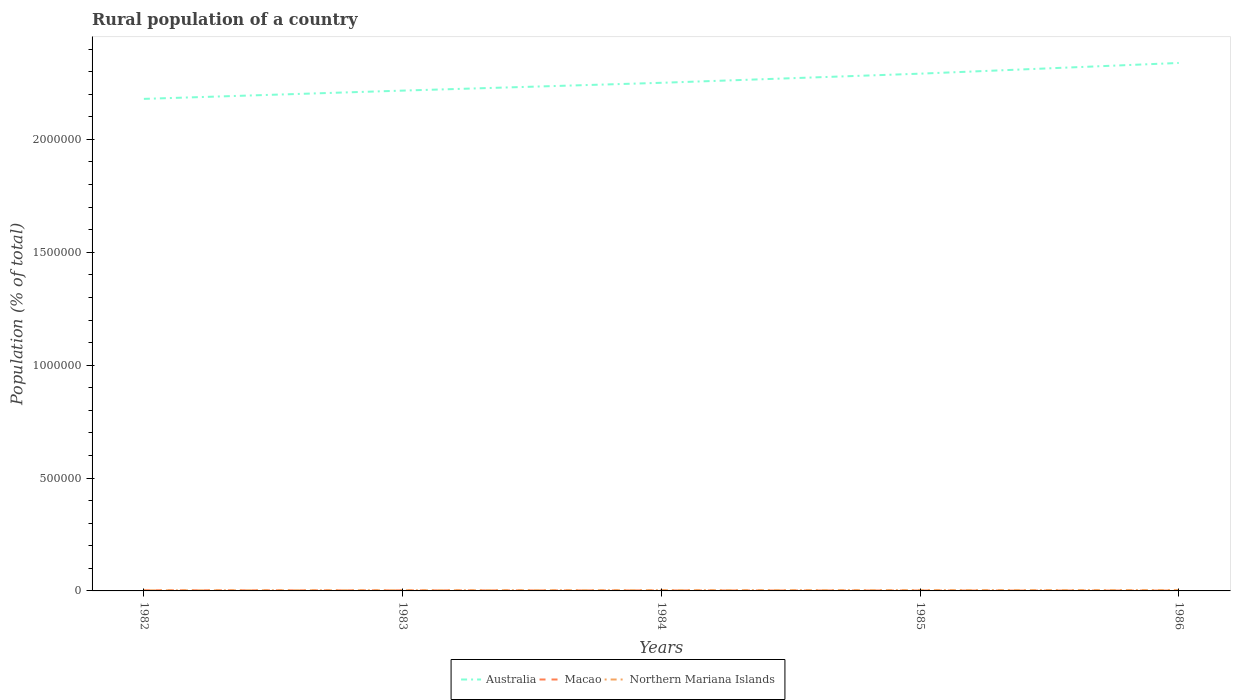Does the line corresponding to Northern Mariana Islands intersect with the line corresponding to Australia?
Your response must be concise. No. Across all years, what is the maximum rural population in Macao?
Keep it short and to the point. 1589. What is the total rural population in Macao in the graph?
Keep it short and to the point. 1310. What is the difference between the highest and the second highest rural population in Northern Mariana Islands?
Offer a terse response. 1070. What is the difference between the highest and the lowest rural population in Macao?
Your answer should be compact. 2. Is the rural population in Macao strictly greater than the rural population in Australia over the years?
Your response must be concise. Yes. Are the values on the major ticks of Y-axis written in scientific E-notation?
Provide a short and direct response. No. Does the graph contain any zero values?
Provide a succinct answer. No. Does the graph contain grids?
Ensure brevity in your answer.  No. Where does the legend appear in the graph?
Offer a terse response. Bottom center. How many legend labels are there?
Make the answer very short. 3. What is the title of the graph?
Your answer should be very brief. Rural population of a country. Does "Cabo Verde" appear as one of the legend labels in the graph?
Provide a short and direct response. No. What is the label or title of the Y-axis?
Offer a terse response. Population (% of total). What is the Population (% of total) of Australia in 1982?
Ensure brevity in your answer.  2.18e+06. What is the Population (% of total) in Macao in 1982?
Keep it short and to the point. 2899. What is the Population (% of total) in Northern Mariana Islands in 1982?
Keep it short and to the point. 2686. What is the Population (% of total) in Australia in 1983?
Your answer should be compact. 2.22e+06. What is the Population (% of total) of Macao in 1983?
Keep it short and to the point. 2489. What is the Population (% of total) in Northern Mariana Islands in 1983?
Give a very brief answer. 2975. What is the Population (% of total) in Australia in 1984?
Your answer should be compact. 2.25e+06. What is the Population (% of total) in Macao in 1984?
Offer a terse response. 2145. What is the Population (% of total) in Northern Mariana Islands in 1984?
Your answer should be very brief. 3263. What is the Population (% of total) in Australia in 1985?
Make the answer very short. 2.29e+06. What is the Population (% of total) in Macao in 1985?
Your response must be concise. 1845. What is the Population (% of total) in Northern Mariana Islands in 1985?
Ensure brevity in your answer.  3525. What is the Population (% of total) in Australia in 1986?
Keep it short and to the point. 2.34e+06. What is the Population (% of total) in Macao in 1986?
Provide a succinct answer. 1589. What is the Population (% of total) of Northern Mariana Islands in 1986?
Give a very brief answer. 3756. Across all years, what is the maximum Population (% of total) in Australia?
Give a very brief answer. 2.34e+06. Across all years, what is the maximum Population (% of total) in Macao?
Offer a very short reply. 2899. Across all years, what is the maximum Population (% of total) of Northern Mariana Islands?
Provide a short and direct response. 3756. Across all years, what is the minimum Population (% of total) of Australia?
Offer a terse response. 2.18e+06. Across all years, what is the minimum Population (% of total) in Macao?
Your answer should be very brief. 1589. Across all years, what is the minimum Population (% of total) in Northern Mariana Islands?
Your answer should be very brief. 2686. What is the total Population (% of total) of Australia in the graph?
Offer a very short reply. 1.13e+07. What is the total Population (% of total) of Macao in the graph?
Your answer should be compact. 1.10e+04. What is the total Population (% of total) in Northern Mariana Islands in the graph?
Ensure brevity in your answer.  1.62e+04. What is the difference between the Population (% of total) of Australia in 1982 and that in 1983?
Make the answer very short. -3.66e+04. What is the difference between the Population (% of total) in Macao in 1982 and that in 1983?
Your answer should be compact. 410. What is the difference between the Population (% of total) of Northern Mariana Islands in 1982 and that in 1983?
Your answer should be compact. -289. What is the difference between the Population (% of total) of Australia in 1982 and that in 1984?
Make the answer very short. -7.12e+04. What is the difference between the Population (% of total) of Macao in 1982 and that in 1984?
Give a very brief answer. 754. What is the difference between the Population (% of total) of Northern Mariana Islands in 1982 and that in 1984?
Your response must be concise. -577. What is the difference between the Population (% of total) in Australia in 1982 and that in 1985?
Offer a terse response. -1.12e+05. What is the difference between the Population (% of total) in Macao in 1982 and that in 1985?
Provide a short and direct response. 1054. What is the difference between the Population (% of total) of Northern Mariana Islands in 1982 and that in 1985?
Give a very brief answer. -839. What is the difference between the Population (% of total) in Australia in 1982 and that in 1986?
Give a very brief answer. -1.59e+05. What is the difference between the Population (% of total) of Macao in 1982 and that in 1986?
Your response must be concise. 1310. What is the difference between the Population (% of total) of Northern Mariana Islands in 1982 and that in 1986?
Make the answer very short. -1070. What is the difference between the Population (% of total) of Australia in 1983 and that in 1984?
Give a very brief answer. -3.46e+04. What is the difference between the Population (% of total) of Macao in 1983 and that in 1984?
Your answer should be compact. 344. What is the difference between the Population (% of total) of Northern Mariana Islands in 1983 and that in 1984?
Provide a succinct answer. -288. What is the difference between the Population (% of total) of Australia in 1983 and that in 1985?
Provide a succinct answer. -7.50e+04. What is the difference between the Population (% of total) of Macao in 1983 and that in 1985?
Offer a very short reply. 644. What is the difference between the Population (% of total) of Northern Mariana Islands in 1983 and that in 1985?
Your answer should be compact. -550. What is the difference between the Population (% of total) in Australia in 1983 and that in 1986?
Keep it short and to the point. -1.22e+05. What is the difference between the Population (% of total) of Macao in 1983 and that in 1986?
Make the answer very short. 900. What is the difference between the Population (% of total) of Northern Mariana Islands in 1983 and that in 1986?
Make the answer very short. -781. What is the difference between the Population (% of total) in Australia in 1984 and that in 1985?
Make the answer very short. -4.04e+04. What is the difference between the Population (% of total) of Macao in 1984 and that in 1985?
Your response must be concise. 300. What is the difference between the Population (% of total) in Northern Mariana Islands in 1984 and that in 1985?
Offer a terse response. -262. What is the difference between the Population (% of total) in Australia in 1984 and that in 1986?
Provide a short and direct response. -8.79e+04. What is the difference between the Population (% of total) in Macao in 1984 and that in 1986?
Give a very brief answer. 556. What is the difference between the Population (% of total) in Northern Mariana Islands in 1984 and that in 1986?
Keep it short and to the point. -493. What is the difference between the Population (% of total) of Australia in 1985 and that in 1986?
Your response must be concise. -4.75e+04. What is the difference between the Population (% of total) in Macao in 1985 and that in 1986?
Ensure brevity in your answer.  256. What is the difference between the Population (% of total) in Northern Mariana Islands in 1985 and that in 1986?
Keep it short and to the point. -231. What is the difference between the Population (% of total) in Australia in 1982 and the Population (% of total) in Macao in 1983?
Give a very brief answer. 2.18e+06. What is the difference between the Population (% of total) in Australia in 1982 and the Population (% of total) in Northern Mariana Islands in 1983?
Provide a succinct answer. 2.18e+06. What is the difference between the Population (% of total) in Macao in 1982 and the Population (% of total) in Northern Mariana Islands in 1983?
Provide a short and direct response. -76. What is the difference between the Population (% of total) in Australia in 1982 and the Population (% of total) in Macao in 1984?
Your answer should be compact. 2.18e+06. What is the difference between the Population (% of total) of Australia in 1982 and the Population (% of total) of Northern Mariana Islands in 1984?
Provide a short and direct response. 2.18e+06. What is the difference between the Population (% of total) in Macao in 1982 and the Population (% of total) in Northern Mariana Islands in 1984?
Your response must be concise. -364. What is the difference between the Population (% of total) in Australia in 1982 and the Population (% of total) in Macao in 1985?
Provide a short and direct response. 2.18e+06. What is the difference between the Population (% of total) in Australia in 1982 and the Population (% of total) in Northern Mariana Islands in 1985?
Keep it short and to the point. 2.18e+06. What is the difference between the Population (% of total) in Macao in 1982 and the Population (% of total) in Northern Mariana Islands in 1985?
Make the answer very short. -626. What is the difference between the Population (% of total) of Australia in 1982 and the Population (% of total) of Macao in 1986?
Your answer should be very brief. 2.18e+06. What is the difference between the Population (% of total) in Australia in 1982 and the Population (% of total) in Northern Mariana Islands in 1986?
Make the answer very short. 2.18e+06. What is the difference between the Population (% of total) in Macao in 1982 and the Population (% of total) in Northern Mariana Islands in 1986?
Keep it short and to the point. -857. What is the difference between the Population (% of total) in Australia in 1983 and the Population (% of total) in Macao in 1984?
Give a very brief answer. 2.21e+06. What is the difference between the Population (% of total) of Australia in 1983 and the Population (% of total) of Northern Mariana Islands in 1984?
Your response must be concise. 2.21e+06. What is the difference between the Population (% of total) of Macao in 1983 and the Population (% of total) of Northern Mariana Islands in 1984?
Offer a very short reply. -774. What is the difference between the Population (% of total) in Australia in 1983 and the Population (% of total) in Macao in 1985?
Your answer should be very brief. 2.21e+06. What is the difference between the Population (% of total) of Australia in 1983 and the Population (% of total) of Northern Mariana Islands in 1985?
Your answer should be compact. 2.21e+06. What is the difference between the Population (% of total) of Macao in 1983 and the Population (% of total) of Northern Mariana Islands in 1985?
Make the answer very short. -1036. What is the difference between the Population (% of total) in Australia in 1983 and the Population (% of total) in Macao in 1986?
Ensure brevity in your answer.  2.21e+06. What is the difference between the Population (% of total) in Australia in 1983 and the Population (% of total) in Northern Mariana Islands in 1986?
Your answer should be compact. 2.21e+06. What is the difference between the Population (% of total) of Macao in 1983 and the Population (% of total) of Northern Mariana Islands in 1986?
Ensure brevity in your answer.  -1267. What is the difference between the Population (% of total) in Australia in 1984 and the Population (% of total) in Macao in 1985?
Offer a very short reply. 2.25e+06. What is the difference between the Population (% of total) of Australia in 1984 and the Population (% of total) of Northern Mariana Islands in 1985?
Offer a very short reply. 2.25e+06. What is the difference between the Population (% of total) in Macao in 1984 and the Population (% of total) in Northern Mariana Islands in 1985?
Offer a terse response. -1380. What is the difference between the Population (% of total) of Australia in 1984 and the Population (% of total) of Macao in 1986?
Offer a terse response. 2.25e+06. What is the difference between the Population (% of total) of Australia in 1984 and the Population (% of total) of Northern Mariana Islands in 1986?
Give a very brief answer. 2.25e+06. What is the difference between the Population (% of total) in Macao in 1984 and the Population (% of total) in Northern Mariana Islands in 1986?
Give a very brief answer. -1611. What is the difference between the Population (% of total) of Australia in 1985 and the Population (% of total) of Macao in 1986?
Keep it short and to the point. 2.29e+06. What is the difference between the Population (% of total) of Australia in 1985 and the Population (% of total) of Northern Mariana Islands in 1986?
Ensure brevity in your answer.  2.29e+06. What is the difference between the Population (% of total) of Macao in 1985 and the Population (% of total) of Northern Mariana Islands in 1986?
Provide a short and direct response. -1911. What is the average Population (% of total) in Australia per year?
Keep it short and to the point. 2.26e+06. What is the average Population (% of total) of Macao per year?
Keep it short and to the point. 2193.4. What is the average Population (% of total) in Northern Mariana Islands per year?
Your answer should be very brief. 3241. In the year 1982, what is the difference between the Population (% of total) of Australia and Population (% of total) of Macao?
Give a very brief answer. 2.18e+06. In the year 1982, what is the difference between the Population (% of total) of Australia and Population (% of total) of Northern Mariana Islands?
Your answer should be very brief. 2.18e+06. In the year 1982, what is the difference between the Population (% of total) in Macao and Population (% of total) in Northern Mariana Islands?
Give a very brief answer. 213. In the year 1983, what is the difference between the Population (% of total) in Australia and Population (% of total) in Macao?
Your response must be concise. 2.21e+06. In the year 1983, what is the difference between the Population (% of total) of Australia and Population (% of total) of Northern Mariana Islands?
Give a very brief answer. 2.21e+06. In the year 1983, what is the difference between the Population (% of total) of Macao and Population (% of total) of Northern Mariana Islands?
Ensure brevity in your answer.  -486. In the year 1984, what is the difference between the Population (% of total) in Australia and Population (% of total) in Macao?
Provide a succinct answer. 2.25e+06. In the year 1984, what is the difference between the Population (% of total) of Australia and Population (% of total) of Northern Mariana Islands?
Make the answer very short. 2.25e+06. In the year 1984, what is the difference between the Population (% of total) in Macao and Population (% of total) in Northern Mariana Islands?
Your answer should be compact. -1118. In the year 1985, what is the difference between the Population (% of total) in Australia and Population (% of total) in Macao?
Provide a short and direct response. 2.29e+06. In the year 1985, what is the difference between the Population (% of total) of Australia and Population (% of total) of Northern Mariana Islands?
Your response must be concise. 2.29e+06. In the year 1985, what is the difference between the Population (% of total) in Macao and Population (% of total) in Northern Mariana Islands?
Offer a very short reply. -1680. In the year 1986, what is the difference between the Population (% of total) of Australia and Population (% of total) of Macao?
Offer a very short reply. 2.34e+06. In the year 1986, what is the difference between the Population (% of total) in Australia and Population (% of total) in Northern Mariana Islands?
Your answer should be very brief. 2.33e+06. In the year 1986, what is the difference between the Population (% of total) of Macao and Population (% of total) of Northern Mariana Islands?
Ensure brevity in your answer.  -2167. What is the ratio of the Population (% of total) in Australia in 1982 to that in 1983?
Make the answer very short. 0.98. What is the ratio of the Population (% of total) of Macao in 1982 to that in 1983?
Make the answer very short. 1.16. What is the ratio of the Population (% of total) of Northern Mariana Islands in 1982 to that in 1983?
Your answer should be compact. 0.9. What is the ratio of the Population (% of total) of Australia in 1982 to that in 1984?
Your answer should be compact. 0.97. What is the ratio of the Population (% of total) in Macao in 1982 to that in 1984?
Keep it short and to the point. 1.35. What is the ratio of the Population (% of total) in Northern Mariana Islands in 1982 to that in 1984?
Give a very brief answer. 0.82. What is the ratio of the Population (% of total) in Australia in 1982 to that in 1985?
Give a very brief answer. 0.95. What is the ratio of the Population (% of total) in Macao in 1982 to that in 1985?
Give a very brief answer. 1.57. What is the ratio of the Population (% of total) in Northern Mariana Islands in 1982 to that in 1985?
Ensure brevity in your answer.  0.76. What is the ratio of the Population (% of total) in Australia in 1982 to that in 1986?
Offer a terse response. 0.93. What is the ratio of the Population (% of total) in Macao in 1982 to that in 1986?
Your answer should be very brief. 1.82. What is the ratio of the Population (% of total) in Northern Mariana Islands in 1982 to that in 1986?
Provide a short and direct response. 0.72. What is the ratio of the Population (% of total) of Australia in 1983 to that in 1984?
Provide a short and direct response. 0.98. What is the ratio of the Population (% of total) in Macao in 1983 to that in 1984?
Provide a succinct answer. 1.16. What is the ratio of the Population (% of total) of Northern Mariana Islands in 1983 to that in 1984?
Give a very brief answer. 0.91. What is the ratio of the Population (% of total) in Australia in 1983 to that in 1985?
Offer a very short reply. 0.97. What is the ratio of the Population (% of total) in Macao in 1983 to that in 1985?
Give a very brief answer. 1.35. What is the ratio of the Population (% of total) in Northern Mariana Islands in 1983 to that in 1985?
Ensure brevity in your answer.  0.84. What is the ratio of the Population (% of total) of Australia in 1983 to that in 1986?
Keep it short and to the point. 0.95. What is the ratio of the Population (% of total) of Macao in 1983 to that in 1986?
Provide a succinct answer. 1.57. What is the ratio of the Population (% of total) of Northern Mariana Islands in 1983 to that in 1986?
Your response must be concise. 0.79. What is the ratio of the Population (% of total) of Australia in 1984 to that in 1985?
Keep it short and to the point. 0.98. What is the ratio of the Population (% of total) of Macao in 1984 to that in 1985?
Keep it short and to the point. 1.16. What is the ratio of the Population (% of total) in Northern Mariana Islands in 1984 to that in 1985?
Make the answer very short. 0.93. What is the ratio of the Population (% of total) in Australia in 1984 to that in 1986?
Your answer should be very brief. 0.96. What is the ratio of the Population (% of total) of Macao in 1984 to that in 1986?
Provide a succinct answer. 1.35. What is the ratio of the Population (% of total) in Northern Mariana Islands in 1984 to that in 1986?
Provide a succinct answer. 0.87. What is the ratio of the Population (% of total) in Australia in 1985 to that in 1986?
Give a very brief answer. 0.98. What is the ratio of the Population (% of total) of Macao in 1985 to that in 1986?
Provide a succinct answer. 1.16. What is the ratio of the Population (% of total) in Northern Mariana Islands in 1985 to that in 1986?
Ensure brevity in your answer.  0.94. What is the difference between the highest and the second highest Population (% of total) of Australia?
Keep it short and to the point. 4.75e+04. What is the difference between the highest and the second highest Population (% of total) of Macao?
Provide a short and direct response. 410. What is the difference between the highest and the second highest Population (% of total) of Northern Mariana Islands?
Give a very brief answer. 231. What is the difference between the highest and the lowest Population (% of total) of Australia?
Your response must be concise. 1.59e+05. What is the difference between the highest and the lowest Population (% of total) in Macao?
Keep it short and to the point. 1310. What is the difference between the highest and the lowest Population (% of total) in Northern Mariana Islands?
Your response must be concise. 1070. 